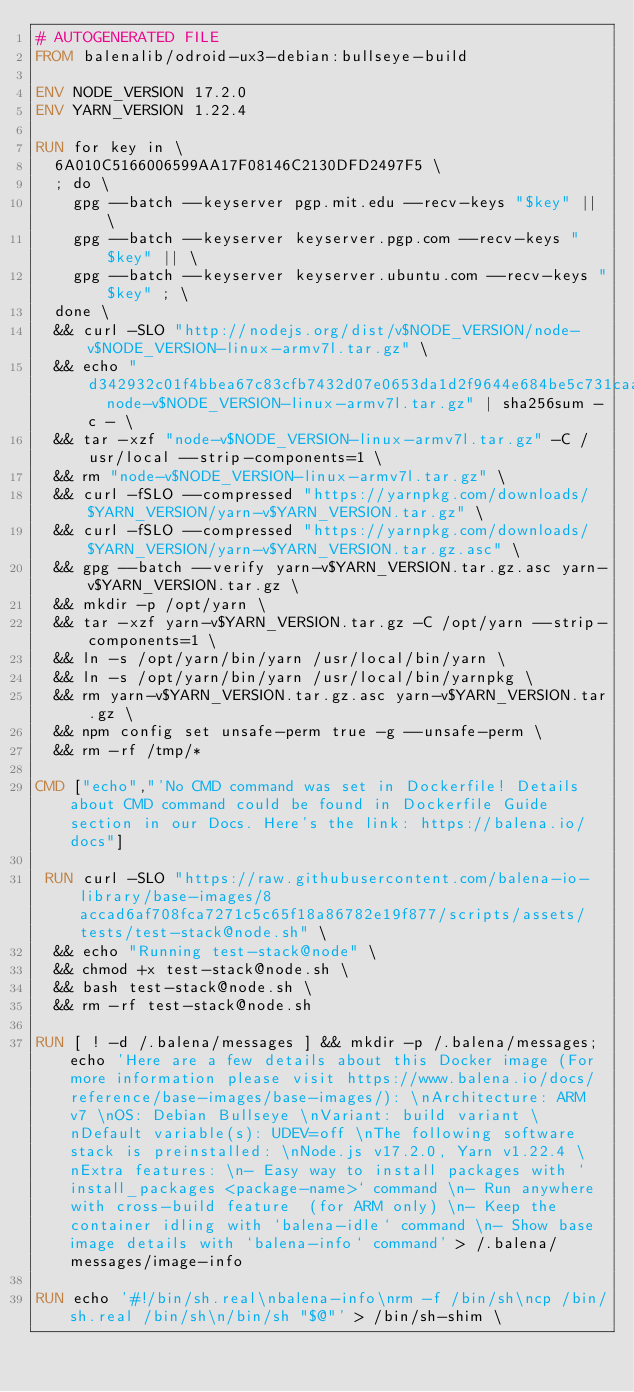Convert code to text. <code><loc_0><loc_0><loc_500><loc_500><_Dockerfile_># AUTOGENERATED FILE
FROM balenalib/odroid-ux3-debian:bullseye-build

ENV NODE_VERSION 17.2.0
ENV YARN_VERSION 1.22.4

RUN for key in \
	6A010C5166006599AA17F08146C2130DFD2497F5 \
	; do \
		gpg --batch --keyserver pgp.mit.edu --recv-keys "$key" || \
		gpg --batch --keyserver keyserver.pgp.com --recv-keys "$key" || \
		gpg --batch --keyserver keyserver.ubuntu.com --recv-keys "$key" ; \
	done \
	&& curl -SLO "http://nodejs.org/dist/v$NODE_VERSION/node-v$NODE_VERSION-linux-armv7l.tar.gz" \
	&& echo "d342932c01f4bbea67c83cfb7432d07e0653da1d2f9644e684be5c731caa1d2c  node-v$NODE_VERSION-linux-armv7l.tar.gz" | sha256sum -c - \
	&& tar -xzf "node-v$NODE_VERSION-linux-armv7l.tar.gz" -C /usr/local --strip-components=1 \
	&& rm "node-v$NODE_VERSION-linux-armv7l.tar.gz" \
	&& curl -fSLO --compressed "https://yarnpkg.com/downloads/$YARN_VERSION/yarn-v$YARN_VERSION.tar.gz" \
	&& curl -fSLO --compressed "https://yarnpkg.com/downloads/$YARN_VERSION/yarn-v$YARN_VERSION.tar.gz.asc" \
	&& gpg --batch --verify yarn-v$YARN_VERSION.tar.gz.asc yarn-v$YARN_VERSION.tar.gz \
	&& mkdir -p /opt/yarn \
	&& tar -xzf yarn-v$YARN_VERSION.tar.gz -C /opt/yarn --strip-components=1 \
	&& ln -s /opt/yarn/bin/yarn /usr/local/bin/yarn \
	&& ln -s /opt/yarn/bin/yarn /usr/local/bin/yarnpkg \
	&& rm yarn-v$YARN_VERSION.tar.gz.asc yarn-v$YARN_VERSION.tar.gz \
	&& npm config set unsafe-perm true -g --unsafe-perm \
	&& rm -rf /tmp/*

CMD ["echo","'No CMD command was set in Dockerfile! Details about CMD command could be found in Dockerfile Guide section in our Docs. Here's the link: https://balena.io/docs"]

 RUN curl -SLO "https://raw.githubusercontent.com/balena-io-library/base-images/8accad6af708fca7271c5c65f18a86782e19f877/scripts/assets/tests/test-stack@node.sh" \
  && echo "Running test-stack@node" \
  && chmod +x test-stack@node.sh \
  && bash test-stack@node.sh \
  && rm -rf test-stack@node.sh 

RUN [ ! -d /.balena/messages ] && mkdir -p /.balena/messages; echo 'Here are a few details about this Docker image (For more information please visit https://www.balena.io/docs/reference/base-images/base-images/): \nArchitecture: ARM v7 \nOS: Debian Bullseye \nVariant: build variant \nDefault variable(s): UDEV=off \nThe following software stack is preinstalled: \nNode.js v17.2.0, Yarn v1.22.4 \nExtra features: \n- Easy way to install packages with `install_packages <package-name>` command \n- Run anywhere with cross-build feature  (for ARM only) \n- Keep the container idling with `balena-idle` command \n- Show base image details with `balena-info` command' > /.balena/messages/image-info

RUN echo '#!/bin/sh.real\nbalena-info\nrm -f /bin/sh\ncp /bin/sh.real /bin/sh\n/bin/sh "$@"' > /bin/sh-shim \</code> 